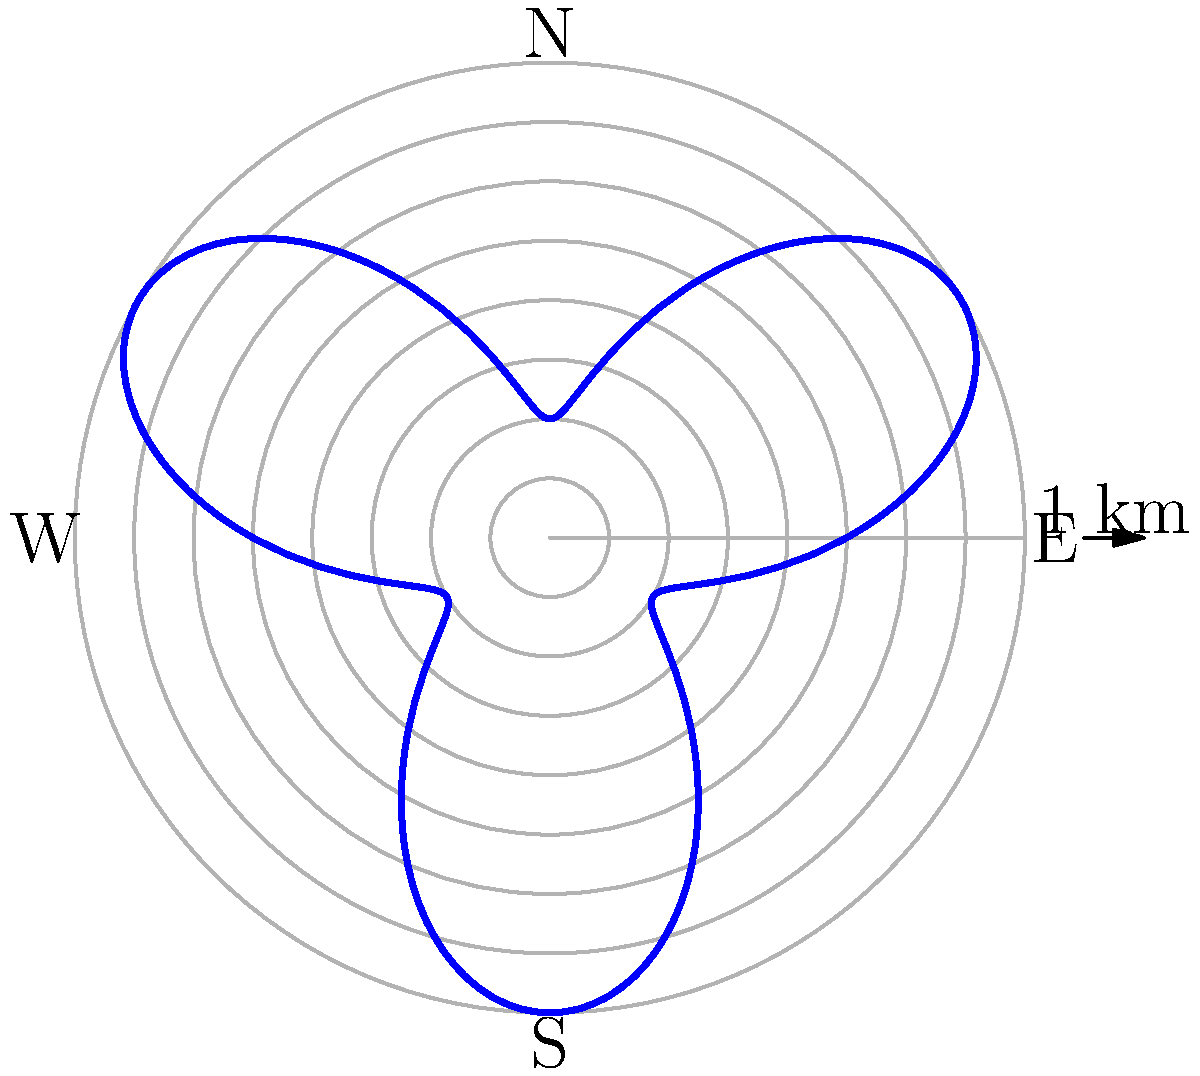The polar graph above represents the coverage area of a new police radar system. The radial distance is measured in kilometers, and the angle represents the direction from the radar's location. What is the maximum range of the radar system, and in which direction(s) does it occur? To answer this question, we need to analyze the polar graph carefully:

1. The graph shows a flower-like pattern with six "petals" or lobes.

2. Each concentric circle represents a distance of 1 km from the center.

3. The blue curve represents the range of the radar system in different directions.

4. To find the maximum range, we need to identify the point(s) where the blue curve extends furthest from the center.

5. Observing the graph, we can see that the curve touches the 8th concentric circle in six places.

6. These maximum points occur at regular intervals, specifically at angles that are multiples of 60° (or π/3 radians) from the positive x-axis.

7. In terms of cardinal directions, these maximum points correspond to:
   - Northeast (30°)
   - Southeast (150°)
   - South (210°)
   - Southwest (270°)
   - Northwest (330°)
   - North (30°)

8. The maximum range is therefore 8 km, occurring in these six directions.
Answer: 8 km; NE, SE, S, SW, NW, N 